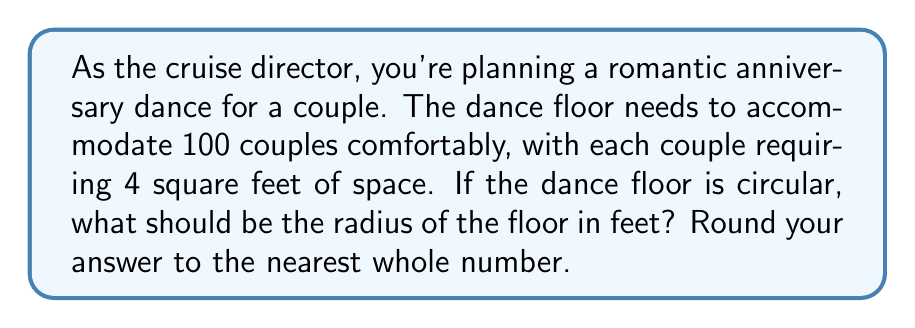What is the answer to this math problem? Let's approach this step-by-step:

1) First, we need to calculate the total area required for all couples:
   100 couples × 4 sq ft per couple = 400 sq ft

2) Now, we know that the area of a circle is given by the formula:
   $A = \pi r^2$
   where $A$ is the area and $r$ is the radius.

3) We can substitute our known area into this formula:
   $400 = \pi r^2$

4) To solve for $r$, we need to divide both sides by $\pi$ and then take the square root:
   $$\begin{align}
   400 &= \pi r^2 \\
   \frac{400}{\pi} &= r^2 \\
   r &= \sqrt{\frac{400}{\pi}}
   \end{align}$$

5) Let's calculate this:
   $r = \sqrt{\frac{400}{\pi}} \approx 11.28$ feet

6) Rounding to the nearest whole number:
   $r \approx 11$ feet

Therefore, the radius of the circular dance floor should be approximately 11 feet.
Answer: 11 feet 